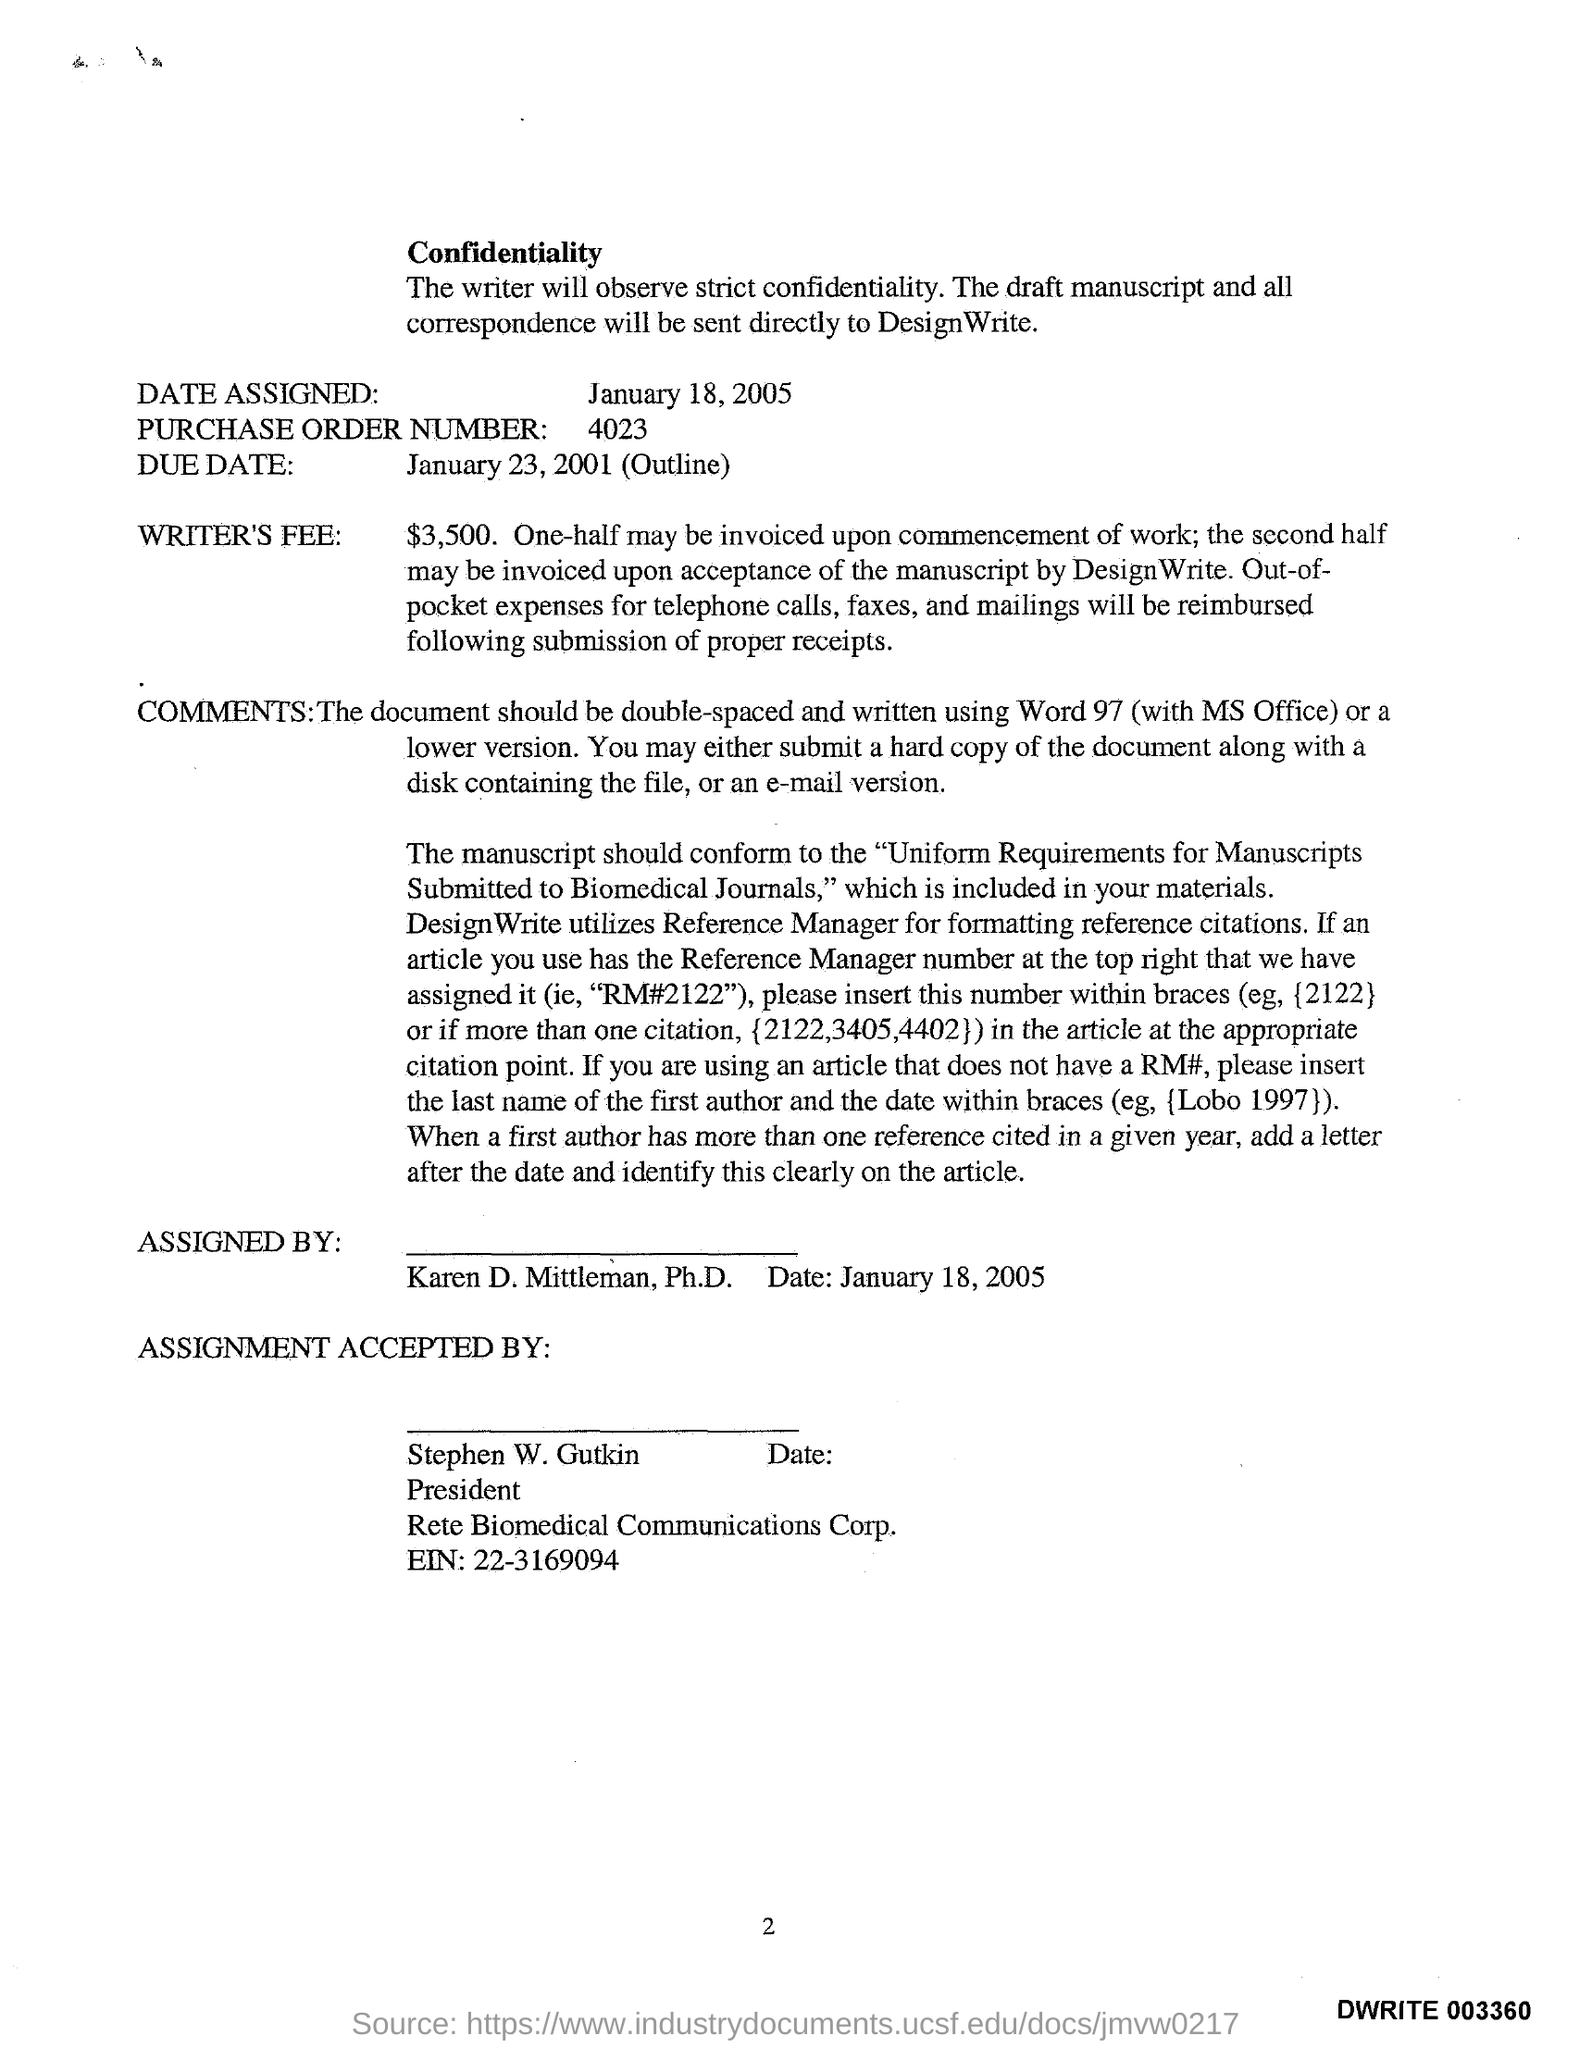Draw attention to some important aspects in this diagram. The Purchase Order Number is 4023. 